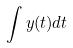Convert formula to latex. <formula><loc_0><loc_0><loc_500><loc_500>\int y ( t ) d t</formula> 